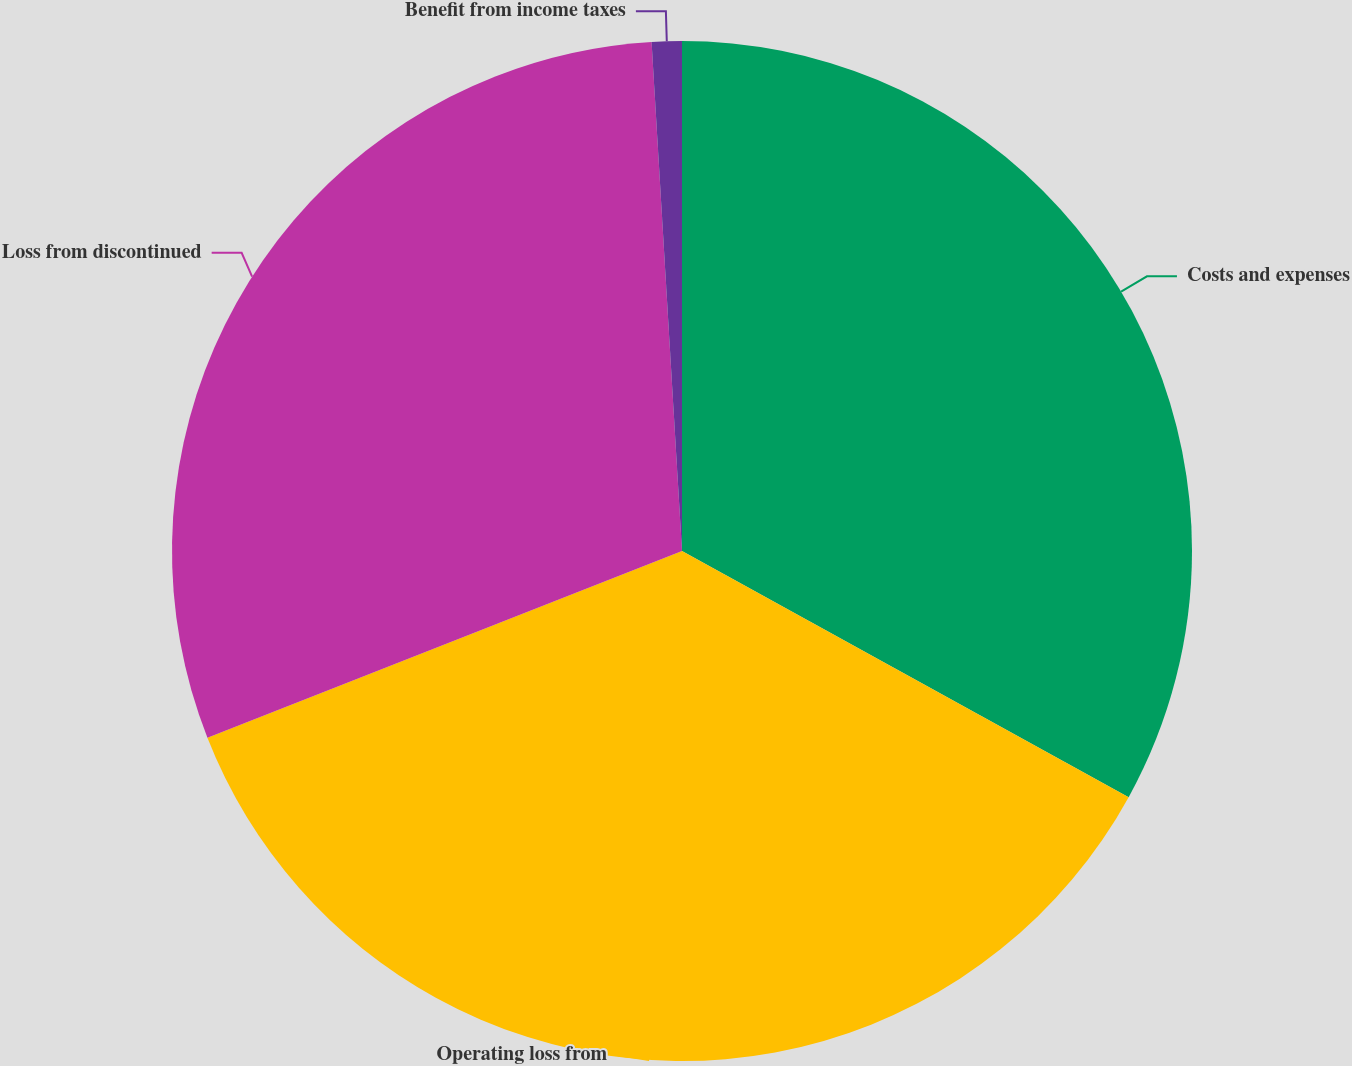Convert chart. <chart><loc_0><loc_0><loc_500><loc_500><pie_chart><fcel>Costs and expenses<fcel>Operating loss from<fcel>Loss from discontinued<fcel>Benefit from income taxes<nl><fcel>33.02%<fcel>36.02%<fcel>30.02%<fcel>0.95%<nl></chart> 